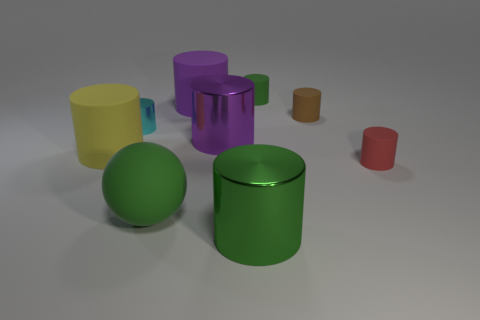Does the tiny red matte thing have the same shape as the tiny shiny object? yes 